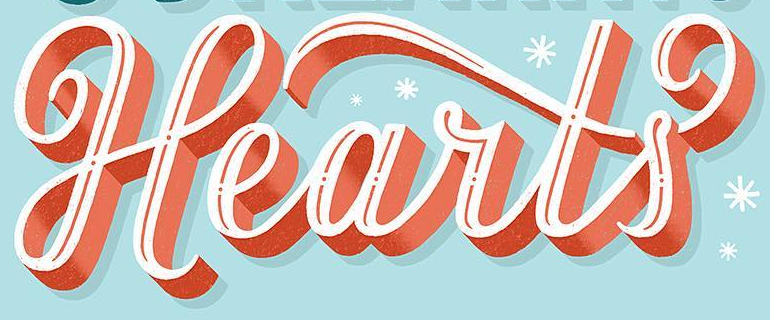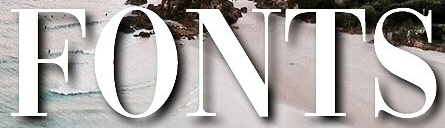Transcribe the words shown in these images in order, separated by a semicolon. Hearts; FONTS 